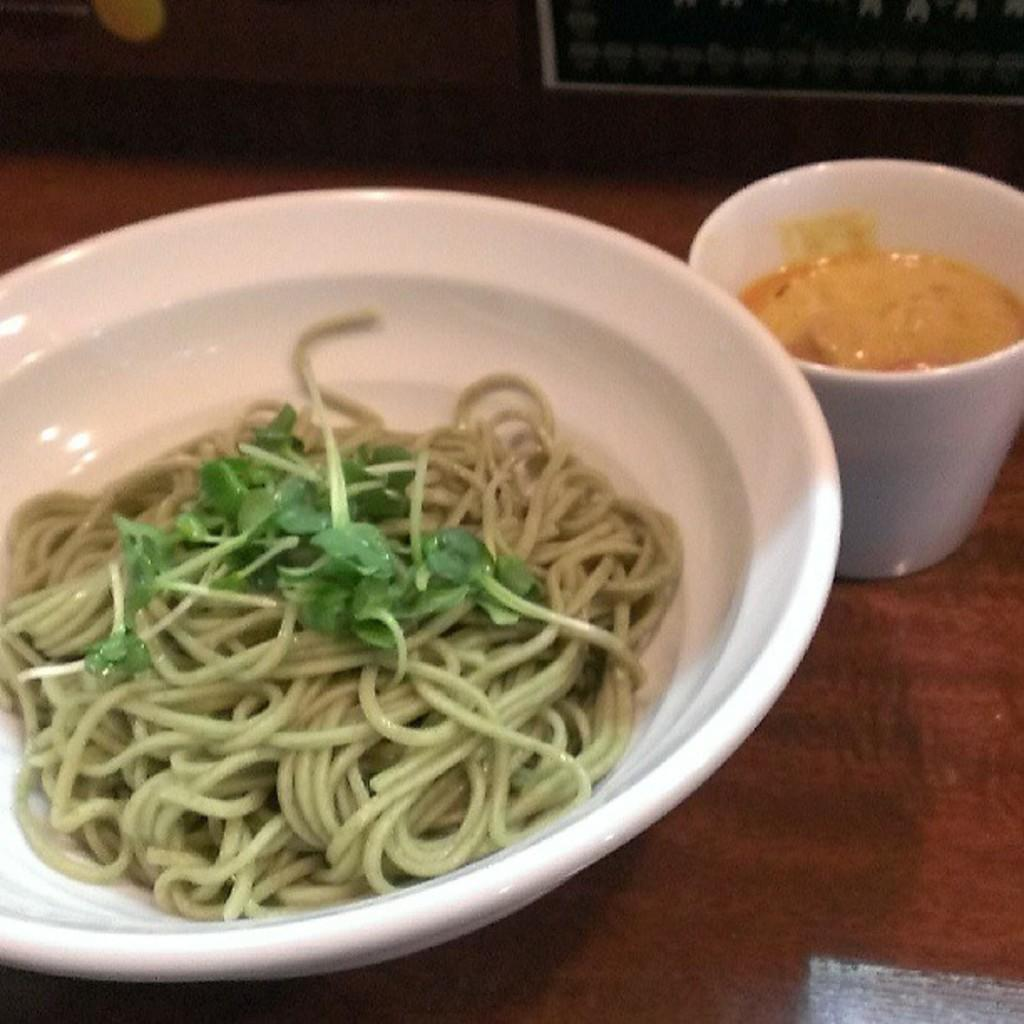What is the main object in the foreground of the image? There is a white bowl in the foreground of the image. What is inside the white bowl? The bowl contains noodles and leafy vegetables. What other object is visible near the bowl? There is a white cup on a wooden surface beside the bowl. Can you describe the background of the image? The background of the image is not clear. How many oranges are on fire in the image? There are no oranges or fire present in the image. 